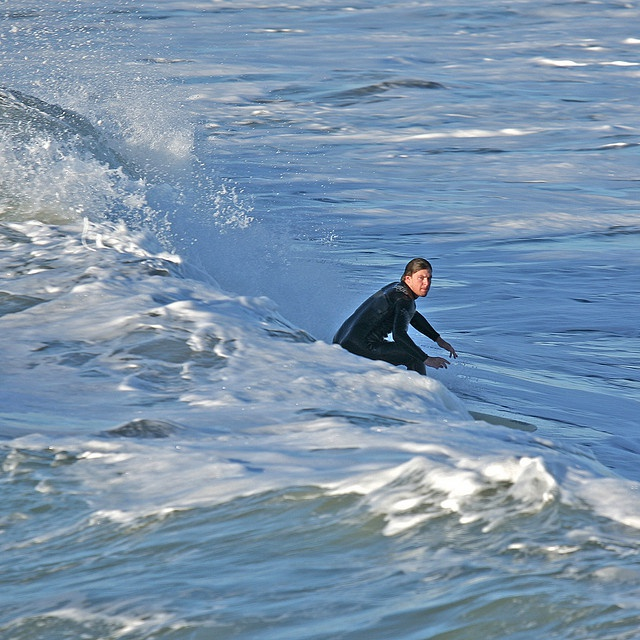Describe the objects in this image and their specific colors. I can see people in gray, black, navy, and blue tones and surfboard in gray and blue tones in this image. 